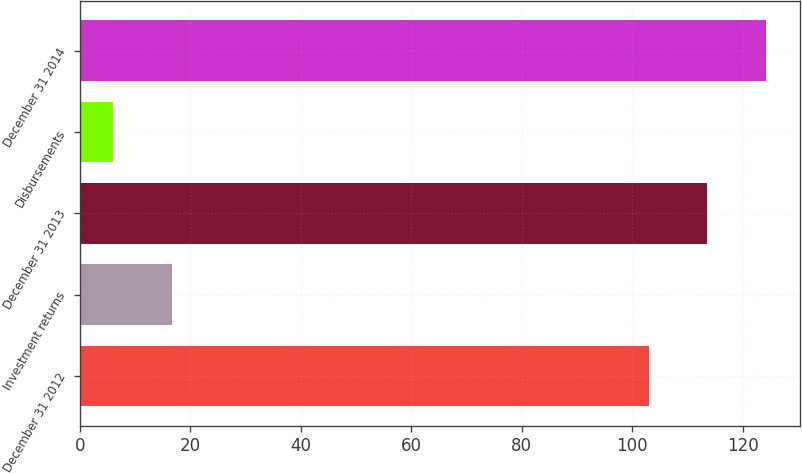Convert chart. <chart><loc_0><loc_0><loc_500><loc_500><bar_chart><fcel>December 31 2012<fcel>Investment returns<fcel>December 31 2013<fcel>Disbursements<fcel>December 31 2014<nl><fcel>103<fcel>16.6<fcel>113.6<fcel>6<fcel>124.2<nl></chart> 